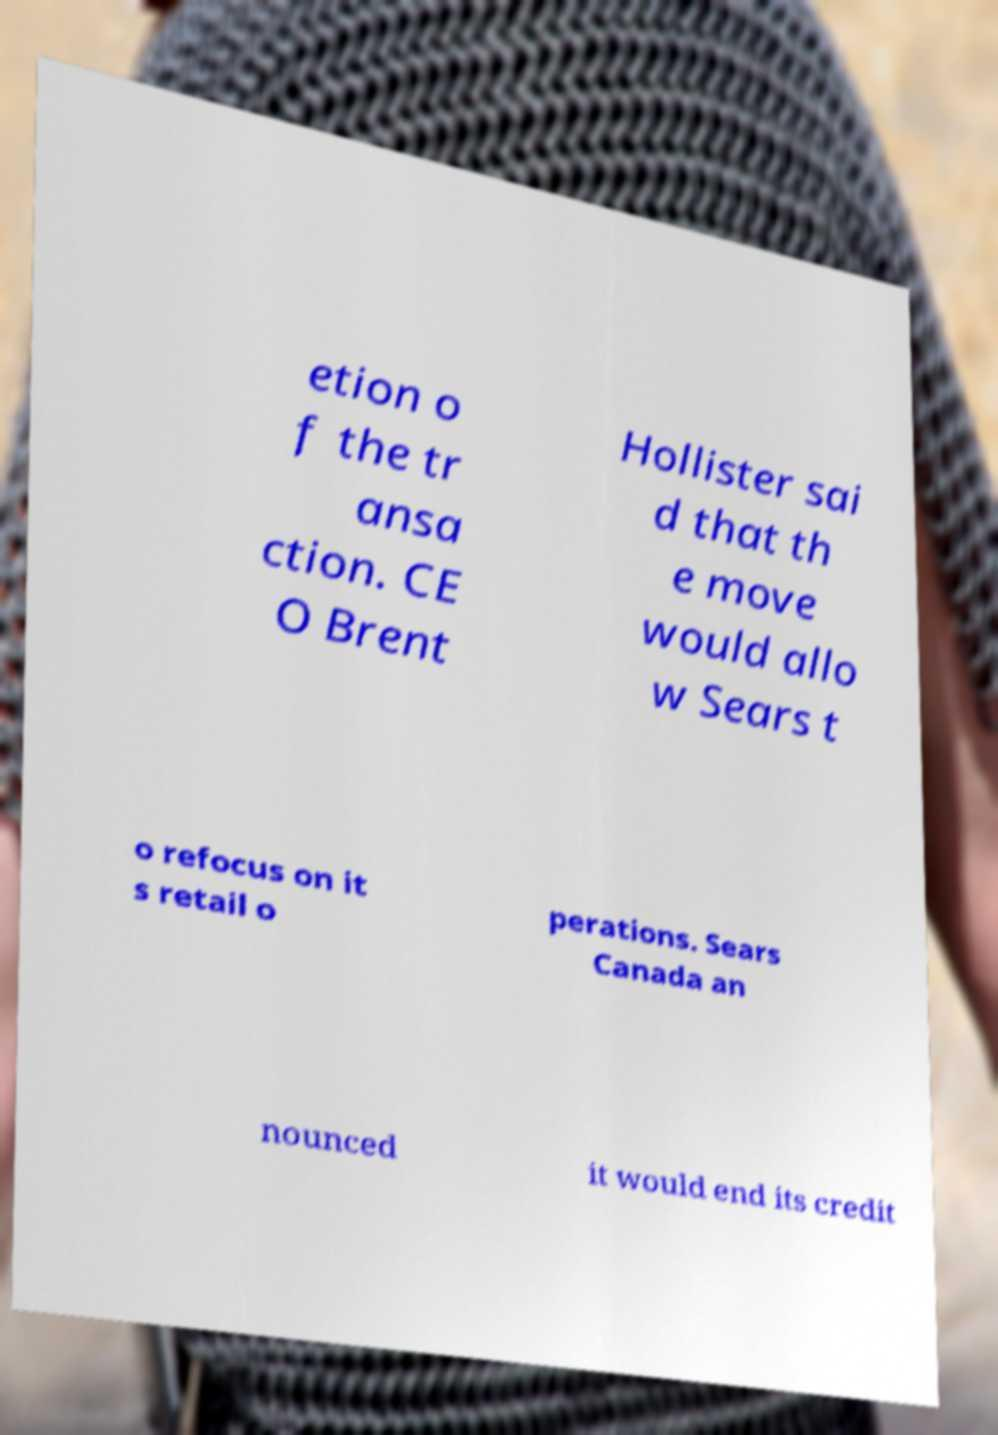For documentation purposes, I need the text within this image transcribed. Could you provide that? etion o f the tr ansa ction. CE O Brent Hollister sai d that th e move would allo w Sears t o refocus on it s retail o perations. Sears Canada an nounced it would end its credit 